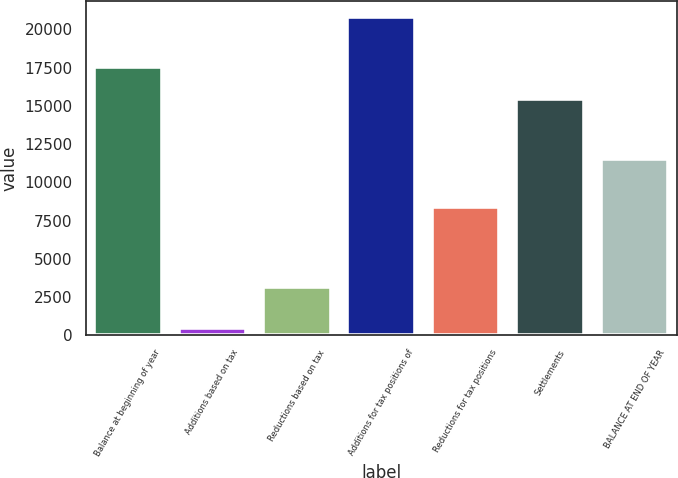<chart> <loc_0><loc_0><loc_500><loc_500><bar_chart><fcel>Balance at beginning of year<fcel>Additions based on tax<fcel>Reductions based on tax<fcel>Additions for tax positions of<fcel>Reductions for tax positions<fcel>Settlements<fcel>BALANCE AT END OF YEAR<nl><fcel>17524<fcel>499<fcel>3124<fcel>20830<fcel>8365<fcel>15475<fcel>11515<nl></chart> 